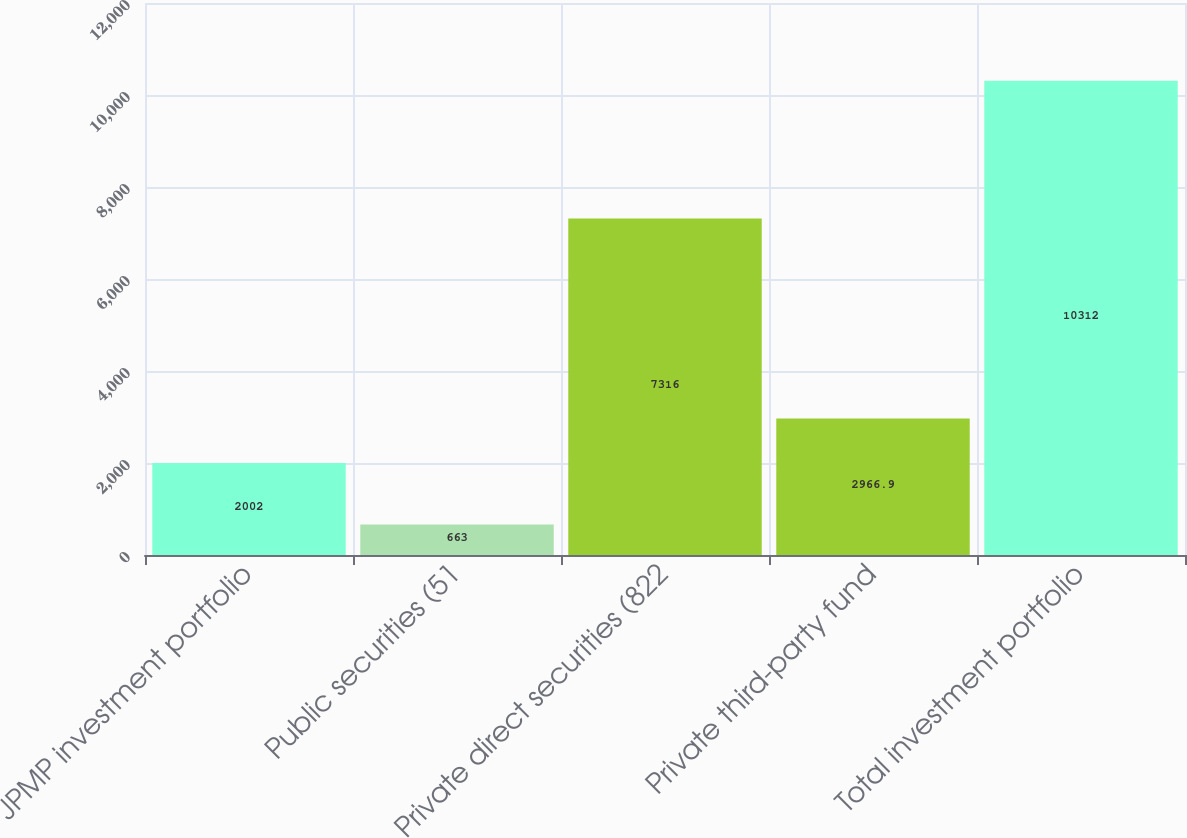<chart> <loc_0><loc_0><loc_500><loc_500><bar_chart><fcel>JPMP investment portfolio<fcel>Public securities (51<fcel>Private direct securities (822<fcel>Private third-party fund<fcel>Total investment portfolio<nl><fcel>2002<fcel>663<fcel>7316<fcel>2966.9<fcel>10312<nl></chart> 